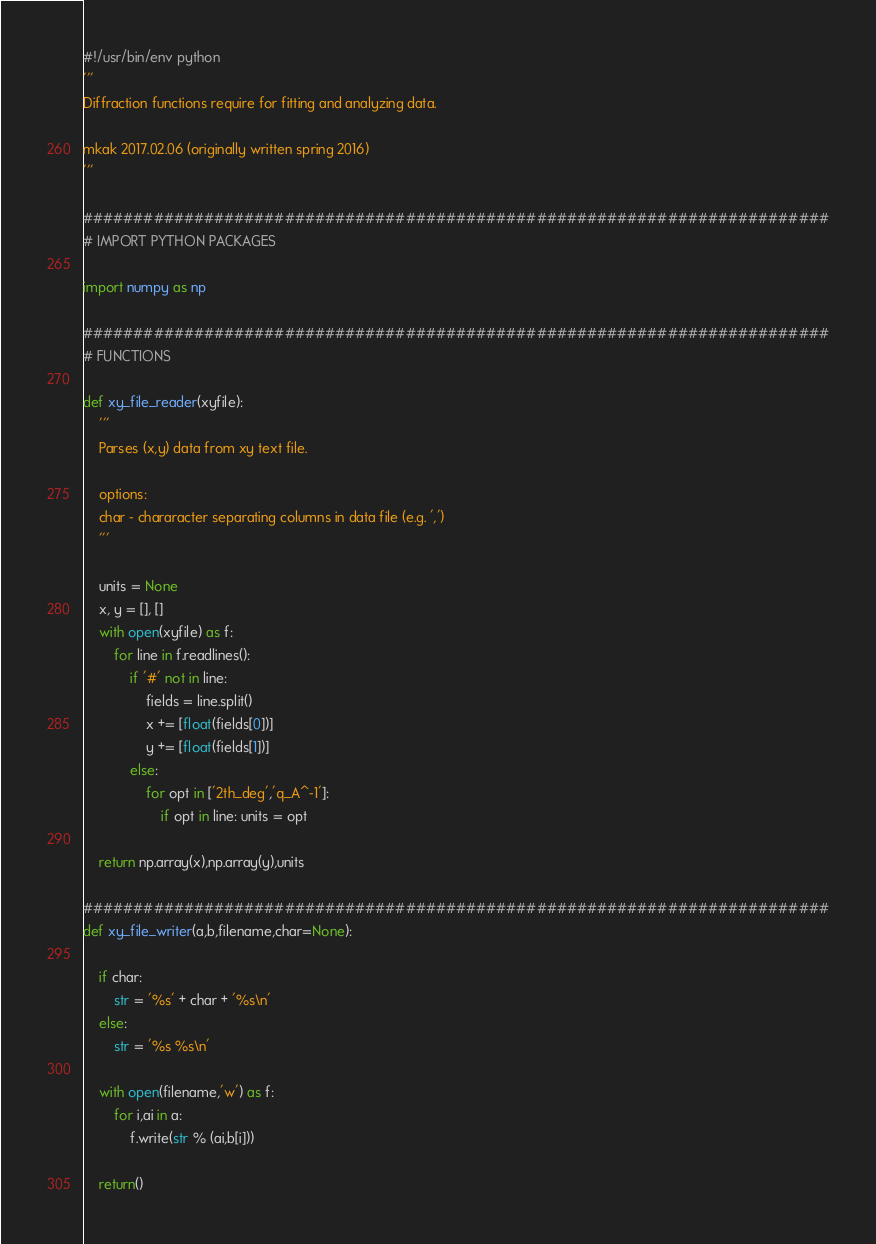Convert code to text. <code><loc_0><loc_0><loc_500><loc_500><_Python_>#!/usr/bin/env python
'''
Diffraction functions require for fitting and analyzing data.

mkak 2017.02.06 (originally written spring 2016)
'''

##########################################################################
# IMPORT PYTHON PACKAGES

import numpy as np

##########################################################################
# FUNCTIONS

def xy_file_reader(xyfile):
    '''
    Parses (x,y) data from xy text file.

    options:
    char - chararacter separating columns in data file (e.g. ',')
    '''

    units = None
    x, y = [], []
    with open(xyfile) as f:
        for line in f.readlines():
            if '#' not in line:
                fields = line.split()
                x += [float(fields[0])]
                y += [float(fields[1])]
            else:
                for opt in ['2th_deg','q_A^-1']:
                    if opt in line: units = opt

    return np.array(x),np.array(y),units

##########################################################################
def xy_file_writer(a,b,filename,char=None):

    if char:
        str = '%s' + char + '%s\n'
    else:
        str = '%s %s\n'

    with open(filename,'w') as f:
        for i,ai in a:
            f.write(str % (ai,b[i]))

    return()
</code> 